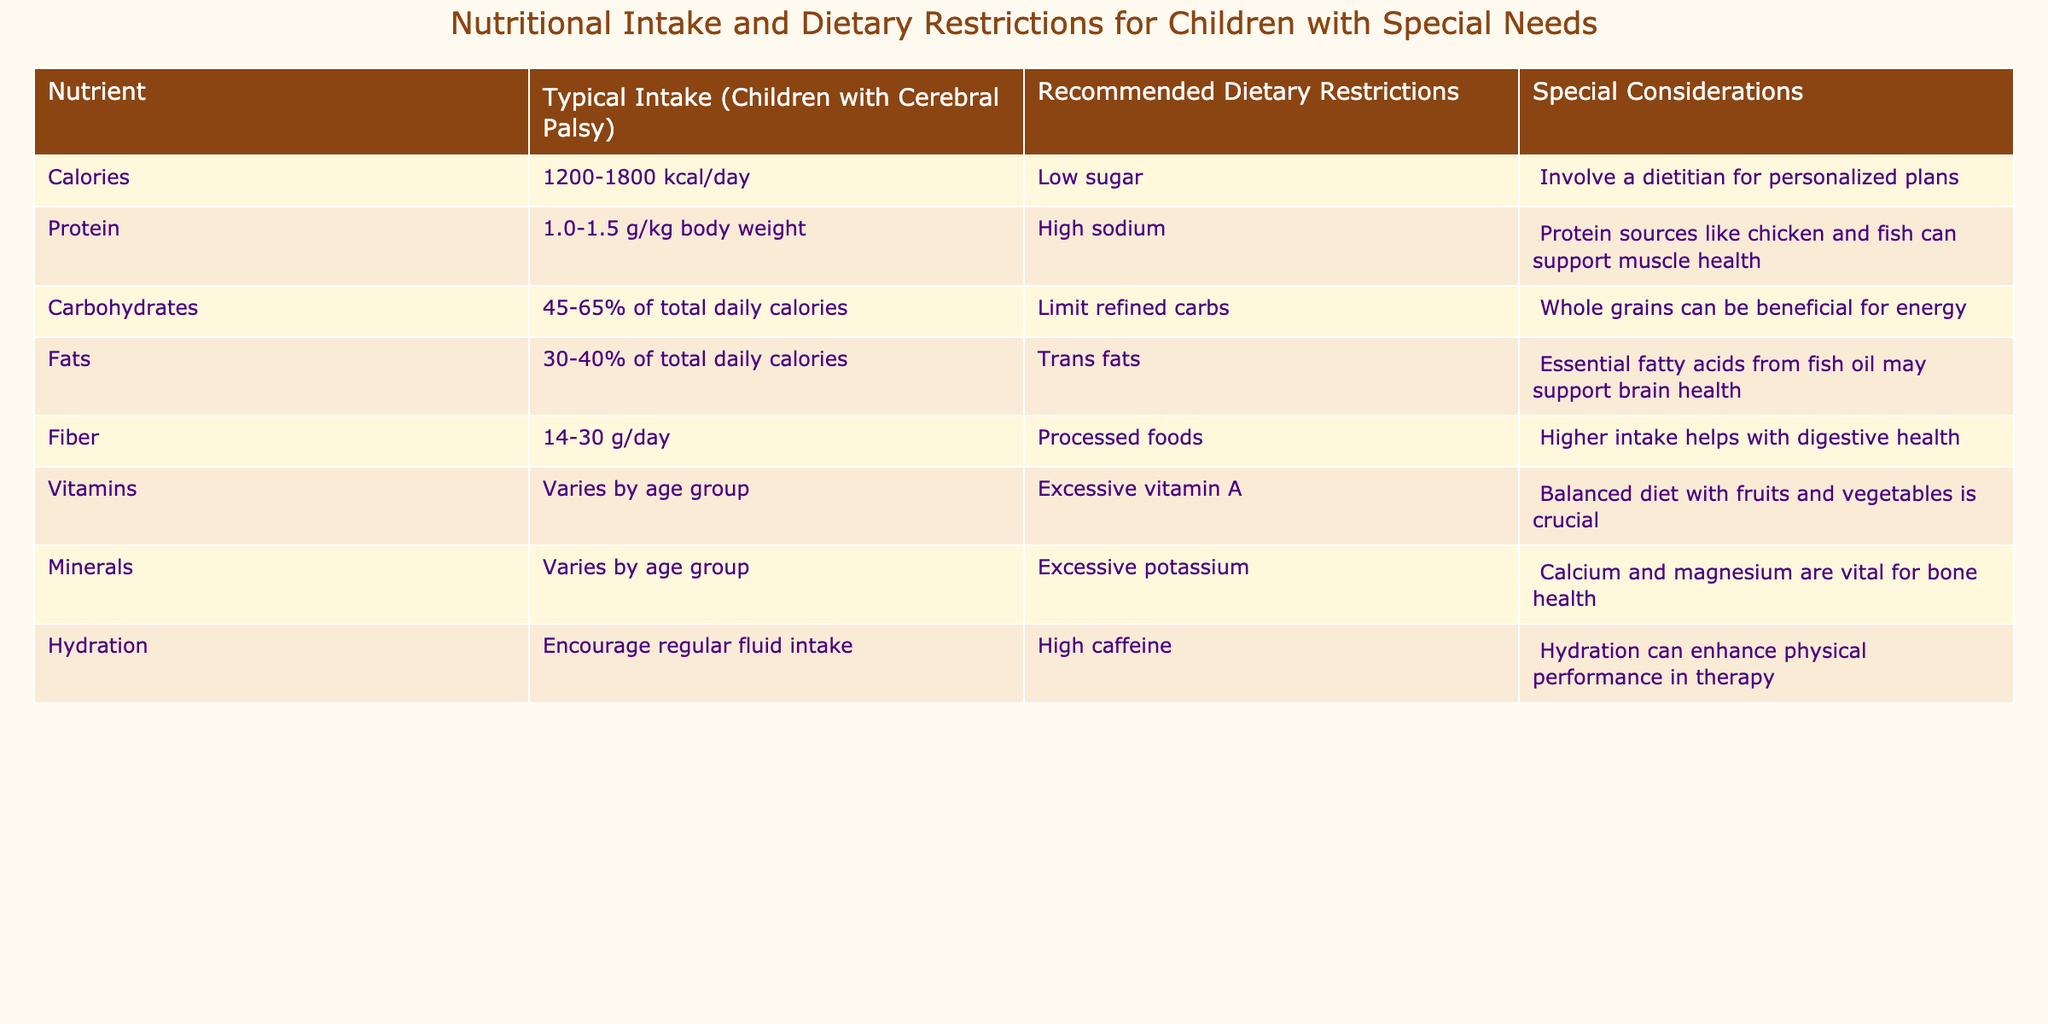What is the typical protein intake for children with cerebral palsy? The table lists the typical protein intake as 1.0-1.5 g/kg body weight for children with cerebral palsy.
Answer: 1.0-1.5 g/kg body weight What dietary restriction is recommended for carbohydrates? According to the table, the recommended dietary restriction for carbohydrates is to limit refined carbs.
Answer: Limit refined carbs How many grams of fiber should children with cerebral palsy aim to consume daily? The table specifies that children with cerebral palsy should aim for 14-30 g of fiber per day.
Answer: 14-30 g/day Is it advised to have high sodium intake for children with cerebral palsy? The table notes that a dietary restriction is to avoid high sodium, so it is not advised.
Answer: No What is the range of daily calorie intake for children with cerebral palsy? The table shows the range of daily calorie intake as 1200-1800 kcal/day for children with cerebral palsy.
Answer: 1200-1800 kcal/day Calculate the average percentage of daily calories from fats if a child consumes the recommended intake. The table states that 30-40% of total daily calories should come from fats. The average is (30+40)/2 = 35%.
Answer: 35% Are essential fatty acids recommended for children with cerebral palsy? The table indicates that essential fatty acids from fish oil may support brain health, suggesting they are recommended.
Answer: Yes If a child's diet included excess potassium, would that be in line with the recommended dietary restrictions? The table indicates that excessive potassium is a restriction for children with special needs, so it would not be in line with recommendations.
Answer: No How does the recommended intake of vitamins vary? The table states that the necessary intake of vitamins varies by age group, which means there is no fixed amount.
Answer: It varies by age group Overall, what percentage of total daily calories from carbohydrates is suggested? The table suggests that carbohydrates should make up 45-65% of total daily calories, thus providing a range rather than a single percentage.
Answer: 45-65% 